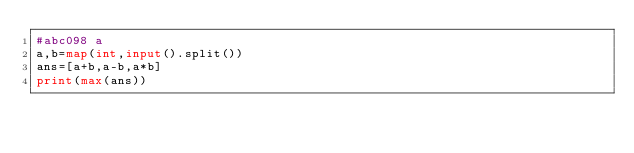<code> <loc_0><loc_0><loc_500><loc_500><_Python_>#abc098 a
a,b=map(int,input().split())
ans=[a+b,a-b,a*b]
print(max(ans))
</code> 